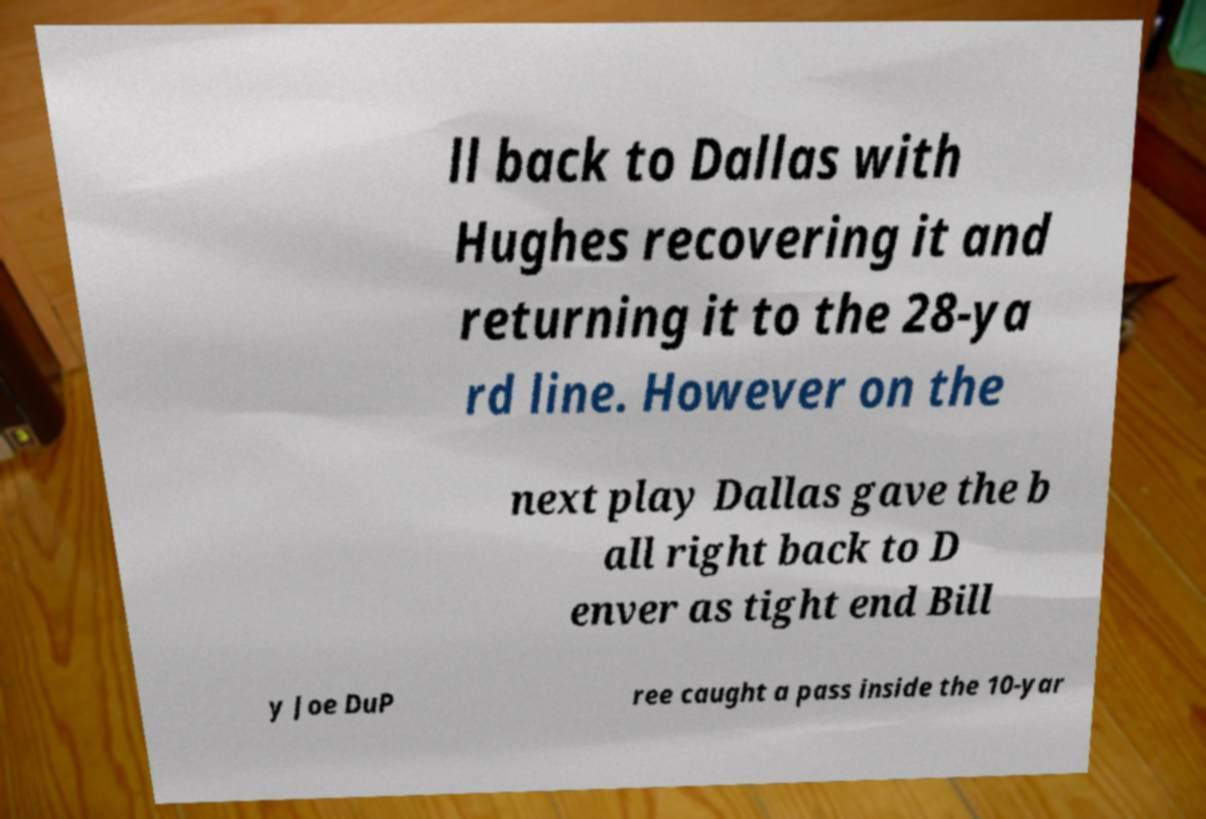Can you read and provide the text displayed in the image?This photo seems to have some interesting text. Can you extract and type it out for me? ll back to Dallas with Hughes recovering it and returning it to the 28-ya rd line. However on the next play Dallas gave the b all right back to D enver as tight end Bill y Joe DuP ree caught a pass inside the 10-yar 